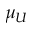Convert formula to latex. <formula><loc_0><loc_0><loc_500><loc_500>\mu _ { U }</formula> 